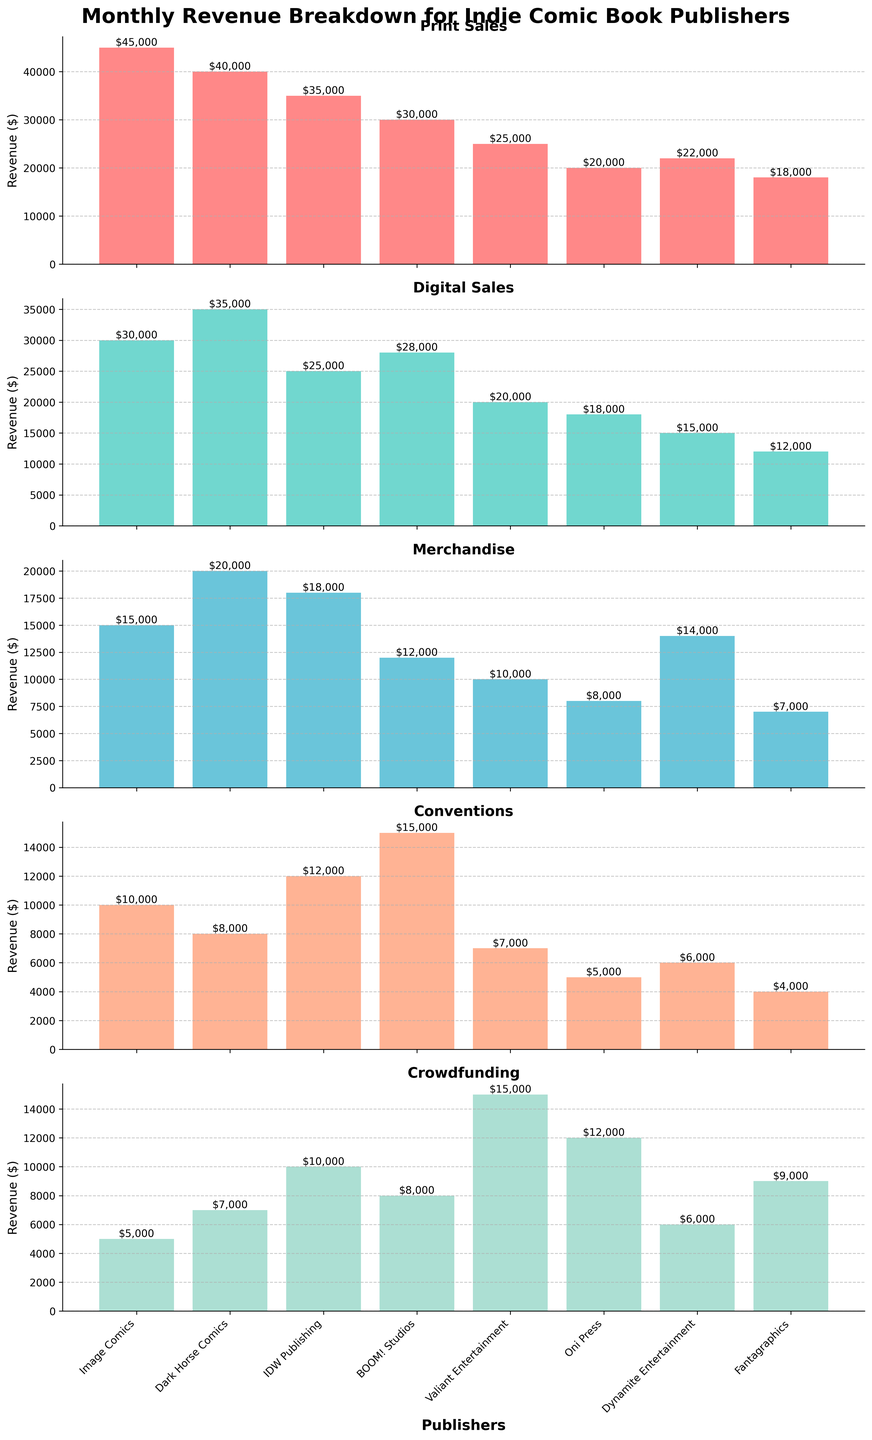Which publisher has the highest print sales? Based on the Print Sales subplot, Image Comics has the highest bar, indicating it has the highest print sales.
Answer: Image Comics Which category has the lowest total revenue among all publishers? First, sum the revenue for each category: Print Sales (210,000), Digital Sales (173,000), Merchandise (104,000), Conventions (62,000), and Crowdfunding (77,000). Conventions have the lowest total revenue.
Answer: Conventions Between BOOM! Studios and Valiant Entertainment, which one has higher digital sales? By observing the Digital Sales subplot, BOOM! Studios has a bar height of 28,000 while Valiant Entertainment has a bar height of 20,000. Therefore, BOOM! Studios has higher digital sales.
Answer: BOOM! Studios What is the print sales revenue of Dark Horse Comics? Refer to the Print Sales subplot and read off the height of the bar for Dark Horse Comics, which is 40,000.
Answer: 40,000 Which publisher relies most on crowdfunding as a revenue source? On the Crowdfunding subplot, Valiant Entertainment has the highest bar, indicating it relies most heavily on crowdfunding.
Answer: Valiant Entertainment Comparing IDW Publishing and Dark Horse Comics, which category shows the largest difference in their revenue? Calculate the differences in each category: Print Sales (5000), Digital Sales (10000), Merchandise (2000), Conventions (4000), Crowdfunding (3000). The largest difference is found in Digital Sales with 10000.
Answer: Digital Sales How many publishers are analyzed in the figure? Count the bars on any subplot (e.g., Print Sales). There are 8 publishers.
Answer: 8 Which category shows the smallest variance in publisher revenues? Compute the variance for each category: Print Sales, Digital Sales, Merchandise, Conventions, Crowdfunding. Crowdfunding shows smaller variation among the publisher revenues.
Answer: Crowdfunding What's the total monthly revenue of Image Comics? Sum the revenues of Print Sales (45000), Digital Sales (30000), Merchandise (15000), Conventions (10000), Crowdfunding (5000).  45000 + 30000 + 15000 + 10000 + 5000 = 105000.
Answer: 105000 Does Fantagraphics earn more from merchandise or conventions? Refer to the Merchandise and Conventions subplots and compare the height of the bars for Fantagraphics. Merchandise revenue is 7000 and Conventions revenue is 4000. Therefore, it earns more from Merchandise.
Answer: Merchandise 